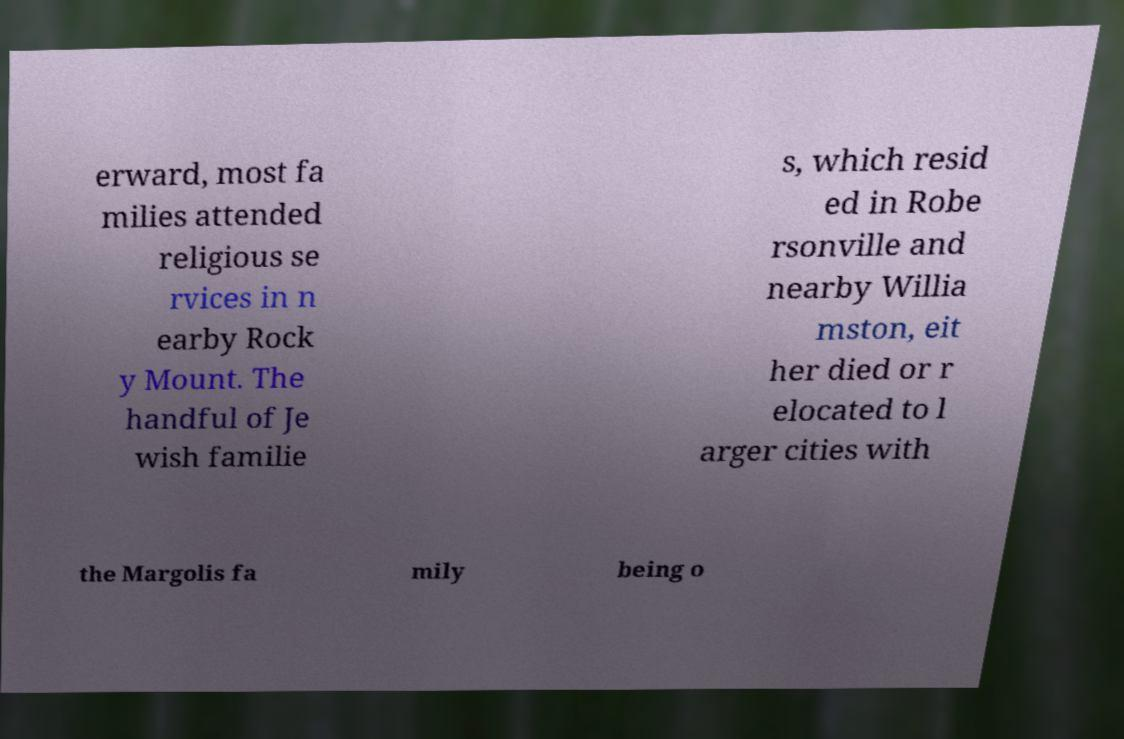Can you read and provide the text displayed in the image?This photo seems to have some interesting text. Can you extract and type it out for me? erward, most fa milies attended religious se rvices in n earby Rock y Mount. The handful of Je wish familie s, which resid ed in Robe rsonville and nearby Willia mston, eit her died or r elocated to l arger cities with the Margolis fa mily being o 